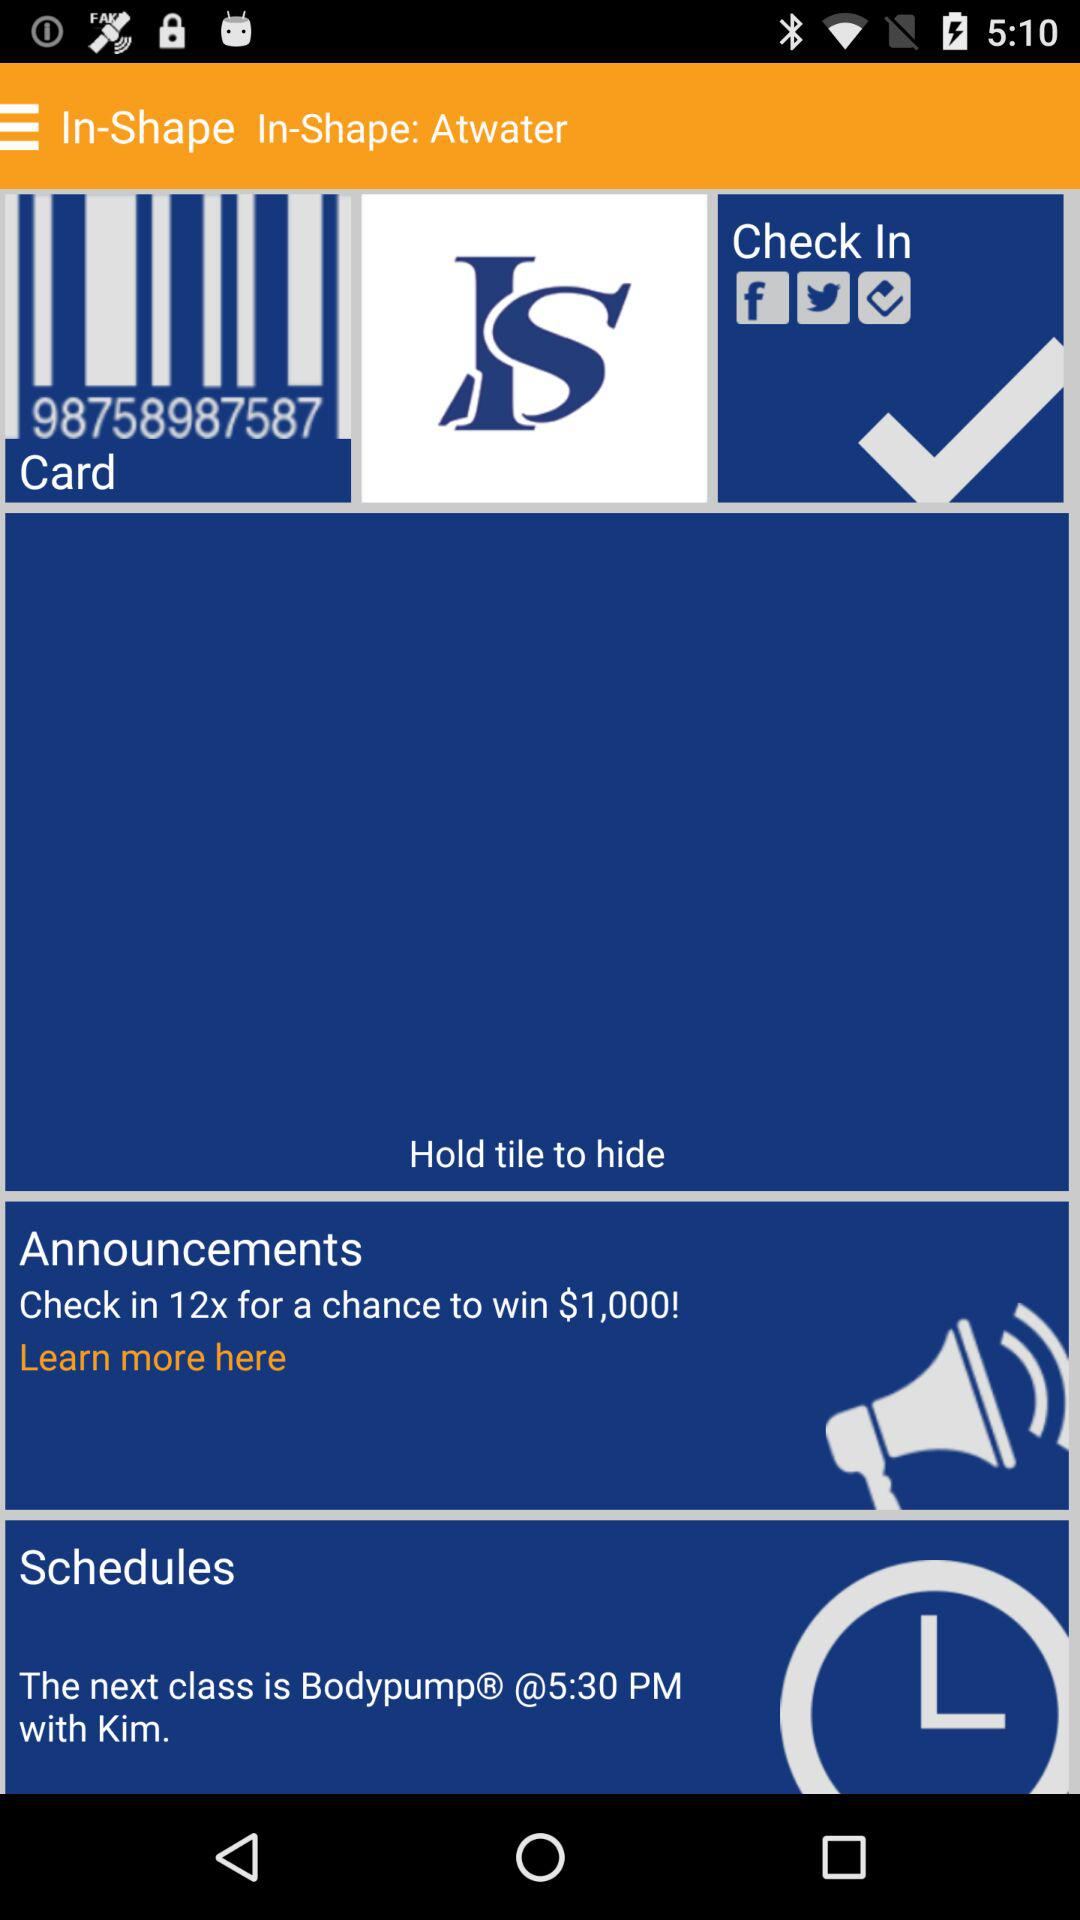How many times has the user checked in already?
When the provided information is insufficient, respond with <no answer>. <no answer> 